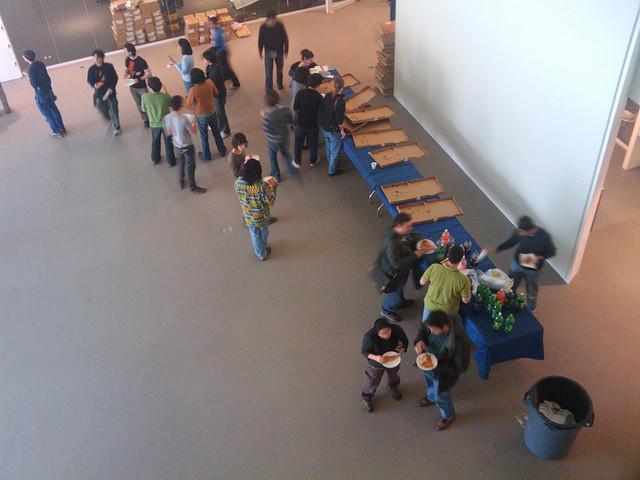How many people can you see?
Give a very brief answer. 8. How many donuts remain?
Give a very brief answer. 0. 